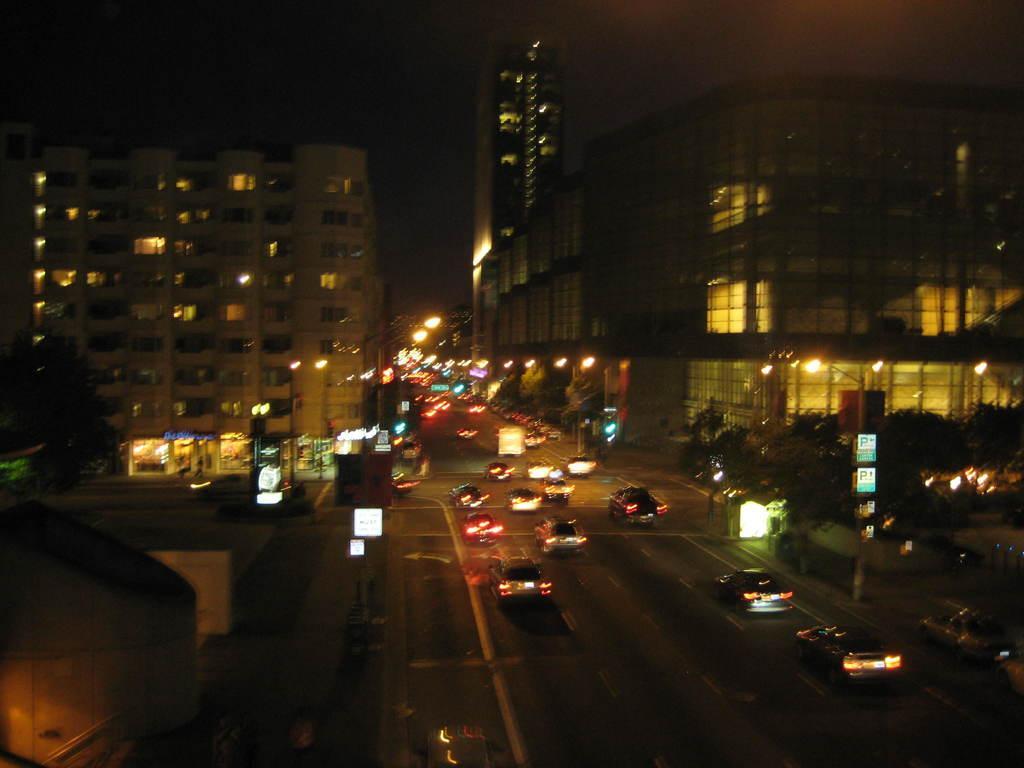In one or two sentences, can you explain what this image depicts? This image is clicked on the roads. There are many vehicles on the road. On the left and right, there are buildings. At the bottom, we can the road. Beside that there are many trees. At the top, there is a sky. 